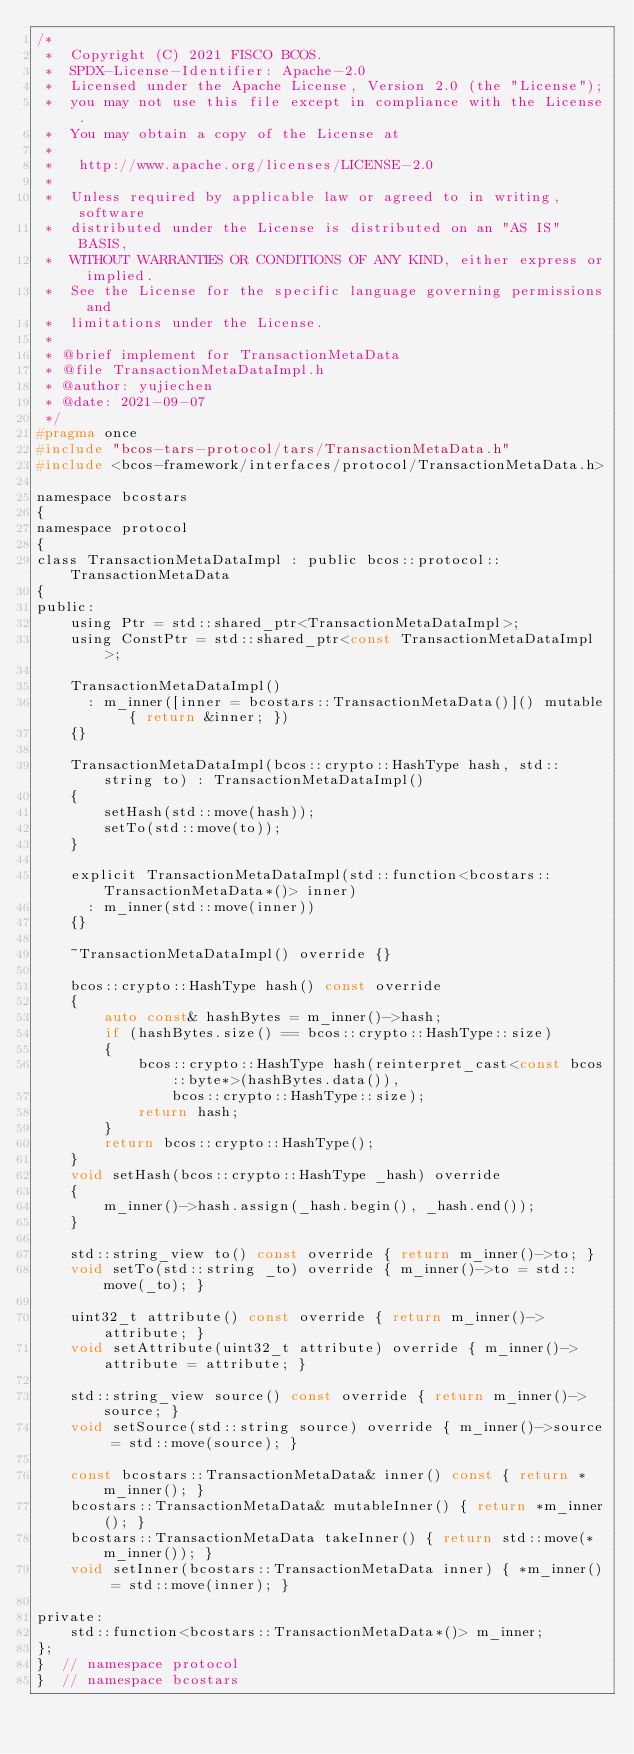Convert code to text. <code><loc_0><loc_0><loc_500><loc_500><_C_>/*
 *  Copyright (C) 2021 FISCO BCOS.
 *  SPDX-License-Identifier: Apache-2.0
 *  Licensed under the Apache License, Version 2.0 (the "License");
 *  you may not use this file except in compliance with the License.
 *  You may obtain a copy of the License at
 *
 *   http://www.apache.org/licenses/LICENSE-2.0
 *
 *  Unless required by applicable law or agreed to in writing, software
 *  distributed under the License is distributed on an "AS IS" BASIS,
 *  WITHOUT WARRANTIES OR CONDITIONS OF ANY KIND, either express or implied.
 *  See the License for the specific language governing permissions and
 *  limitations under the License.
 *
 * @brief implement for TransactionMetaData
 * @file TransactionMetaDataImpl.h
 * @author: yujiechen
 * @date: 2021-09-07
 */
#pragma once
#include "bcos-tars-protocol/tars/TransactionMetaData.h"
#include <bcos-framework/interfaces/protocol/TransactionMetaData.h>

namespace bcostars
{
namespace protocol
{
class TransactionMetaDataImpl : public bcos::protocol::TransactionMetaData
{
public:
    using Ptr = std::shared_ptr<TransactionMetaDataImpl>;
    using ConstPtr = std::shared_ptr<const TransactionMetaDataImpl>;

    TransactionMetaDataImpl()
      : m_inner([inner = bcostars::TransactionMetaData()]() mutable { return &inner; })
    {}

    TransactionMetaDataImpl(bcos::crypto::HashType hash, std::string to) : TransactionMetaDataImpl()
    {
        setHash(std::move(hash));
        setTo(std::move(to));
    }

    explicit TransactionMetaDataImpl(std::function<bcostars::TransactionMetaData*()> inner)
      : m_inner(std::move(inner))
    {}

    ~TransactionMetaDataImpl() override {}

    bcos::crypto::HashType hash() const override
    {
        auto const& hashBytes = m_inner()->hash;
        if (hashBytes.size() == bcos::crypto::HashType::size)
        {
            bcos::crypto::HashType hash(reinterpret_cast<const bcos::byte*>(hashBytes.data()),
                bcos::crypto::HashType::size);
            return hash;
        }
        return bcos::crypto::HashType();
    }
    void setHash(bcos::crypto::HashType _hash) override
    {
        m_inner()->hash.assign(_hash.begin(), _hash.end());
    }

    std::string_view to() const override { return m_inner()->to; }
    void setTo(std::string _to) override { m_inner()->to = std::move(_to); }

    uint32_t attribute() const override { return m_inner()->attribute; }
    void setAttribute(uint32_t attribute) override { m_inner()->attribute = attribute; }

    std::string_view source() const override { return m_inner()->source; }
    void setSource(std::string source) override { m_inner()->source = std::move(source); }

    const bcostars::TransactionMetaData& inner() const { return *m_inner(); }
    bcostars::TransactionMetaData& mutableInner() { return *m_inner(); }
    bcostars::TransactionMetaData takeInner() { return std::move(*m_inner()); }
    void setInner(bcostars::TransactionMetaData inner) { *m_inner() = std::move(inner); }

private:
    std::function<bcostars::TransactionMetaData*()> m_inner;
};
}  // namespace protocol
}  // namespace bcostars
</code> 